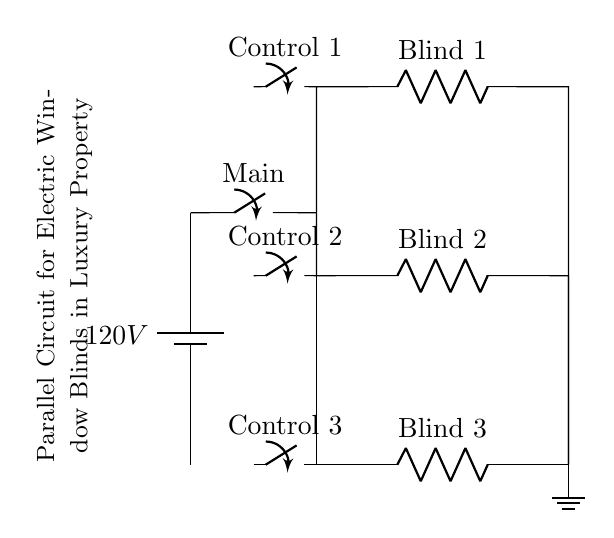What is the voltage provided by the power source? The voltage is labeled as 120 volts, which is indicated at the battery symbol. This represents the potential difference supplied to the circuit.
Answer: 120 volts How many electric blinds are connected in parallel? There are three resistors labeled as Blind 1, Blind 2, and Blind 3. Since these resistors are branches connected across the same voltage source, they represent the electric blinds operating in parallel.
Answer: Three What is the function of the main switch? The main switch allows or interrupts the flow of current to the entire circuit, controlling the power supply to the connected devices (electric blinds).
Answer: Control power Which component would you operate to control Blind 2? To control Blind 2, you would operate the switch labeled Control 2, which is directly connected to Blind 2's circuit branch. This allows for individual control of that specific blind.
Answer: Control 2 What is the relationship between the blinds in this circuit? The blinds are connected in parallel, meaning each blind operates independently of the others, receiving the same voltage while allowing for separate operation.
Answer: Independent operation Which part of the circuit is grounded? The ground symbol is located at the bottom of the circuit diagram, indicating that the lowest point of the circuit (where all the blinds connect) is grounded to provide a return path for the current.
Answer: Ground 